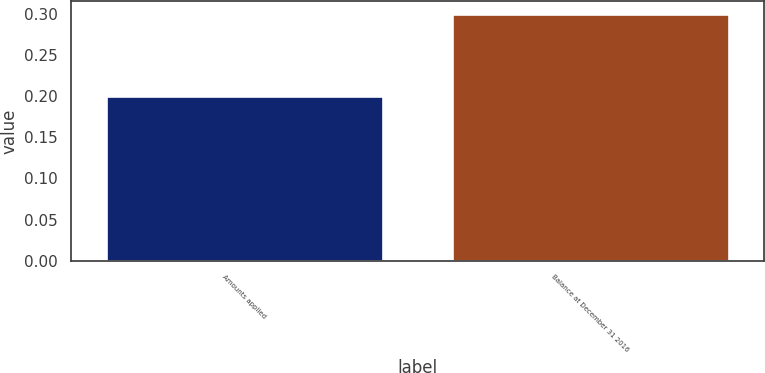Convert chart. <chart><loc_0><loc_0><loc_500><loc_500><bar_chart><fcel>Amounts applied<fcel>Balance at December 31 2016<nl><fcel>0.2<fcel>0.3<nl></chart> 